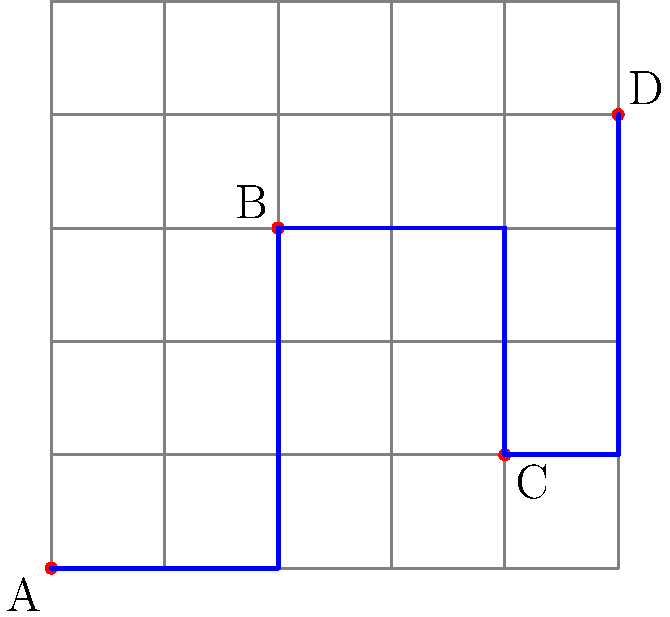As a political strategist planning a campaign tour, you need to determine the shortest path between four campaign stops (A, B, C, and D) on a city grid. The grid is laid out such that each block is 1 unit long. Given the coordinates of the stops as A(0,0), B(2,3), C(4,1), and D(5,4), what is the total distance of the shortest path visiting all stops in alphabetical order? To find the shortest path between the campaign stops on a city grid, we need to use the Manhattan distance (also known as taxicab geometry) between each pair of consecutive points. The Manhattan distance is the sum of the absolute differences of the coordinates.

Let's calculate the distance between each pair of stops:

1. From A(0,0) to B(2,3):
   $|2-0| + |3-0| = 2 + 3 = 5$ units

2. From B(2,3) to C(4,1):
   $|4-2| + |1-3| = 2 + 2 = 4$ units

3. From C(4,1) to D(5,4):
   $|5-4| + |4-1| = 1 + 3 = 4$ units

The total distance is the sum of these individual distances:

$5 + 4 + 4 = 13$ units

This path follows the blue line on the grid, which represents the optimal route:
- From A to B: 2 blocks east, then 3 blocks north
- From B to C: 2 blocks east, then 2 blocks south
- From C to D: 1 block east, then 3 blocks north

Therefore, the total distance of the shortest path visiting all stops in alphabetical order is 13 units.
Answer: 13 units 